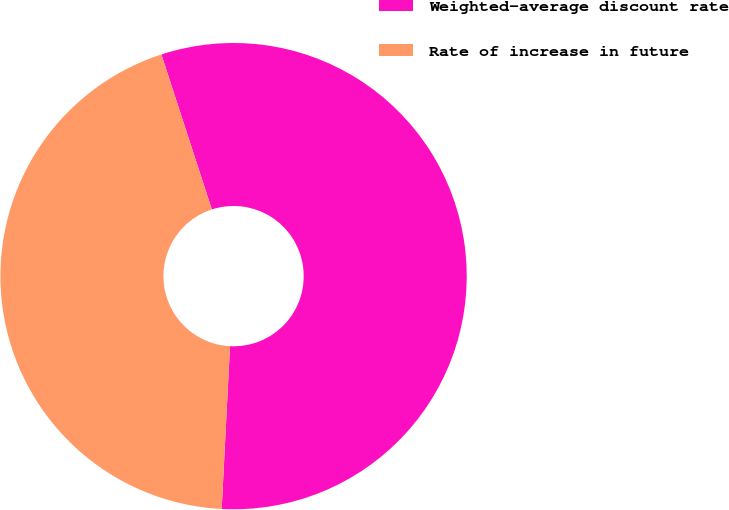Convert chart to OTSL. <chart><loc_0><loc_0><loc_500><loc_500><pie_chart><fcel>Weighted-average discount rate<fcel>Rate of increase in future<nl><fcel>55.82%<fcel>44.18%<nl></chart> 